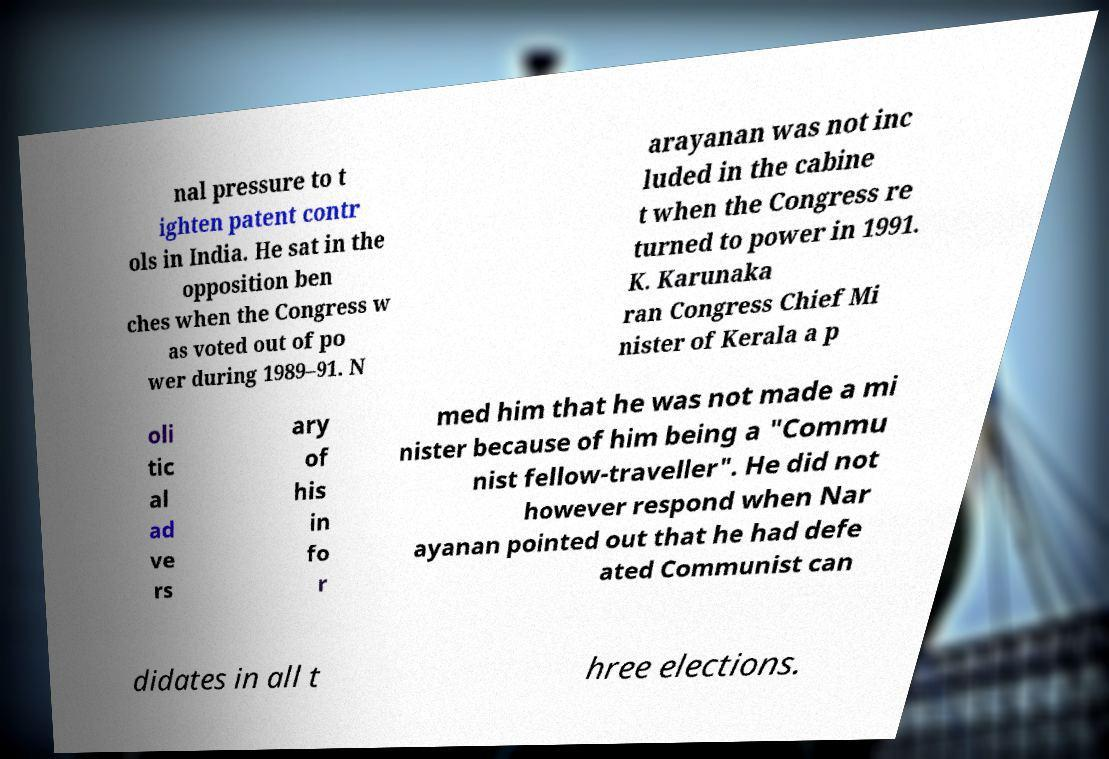What messages or text are displayed in this image? I need them in a readable, typed format. nal pressure to t ighten patent contr ols in India. He sat in the opposition ben ches when the Congress w as voted out of po wer during 1989–91. N arayanan was not inc luded in the cabine t when the Congress re turned to power in 1991. K. Karunaka ran Congress Chief Mi nister of Kerala a p oli tic al ad ve rs ary of his in fo r med him that he was not made a mi nister because of him being a "Commu nist fellow-traveller". He did not however respond when Nar ayanan pointed out that he had defe ated Communist can didates in all t hree elections. 